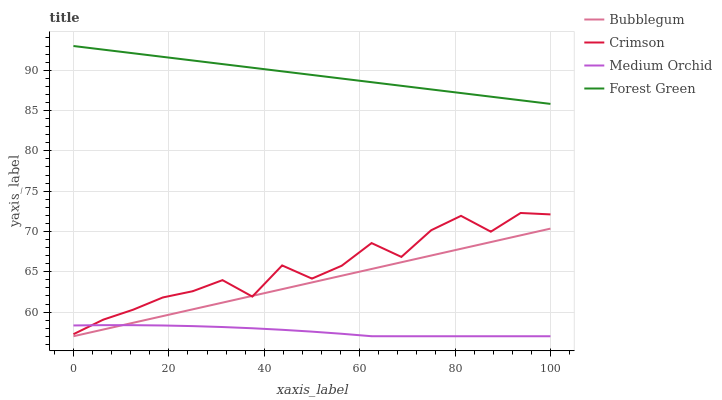Does Medium Orchid have the minimum area under the curve?
Answer yes or no. Yes. Does Forest Green have the maximum area under the curve?
Answer yes or no. Yes. Does Forest Green have the minimum area under the curve?
Answer yes or no. No. Does Medium Orchid have the maximum area under the curve?
Answer yes or no. No. Is Bubblegum the smoothest?
Answer yes or no. Yes. Is Crimson the roughest?
Answer yes or no. Yes. Is Forest Green the smoothest?
Answer yes or no. No. Is Forest Green the roughest?
Answer yes or no. No. Does Medium Orchid have the lowest value?
Answer yes or no. Yes. Does Forest Green have the lowest value?
Answer yes or no. No. Does Forest Green have the highest value?
Answer yes or no. Yes. Does Medium Orchid have the highest value?
Answer yes or no. No. Is Crimson less than Forest Green?
Answer yes or no. Yes. Is Forest Green greater than Bubblegum?
Answer yes or no. Yes. Does Crimson intersect Bubblegum?
Answer yes or no. Yes. Is Crimson less than Bubblegum?
Answer yes or no. No. Is Crimson greater than Bubblegum?
Answer yes or no. No. Does Crimson intersect Forest Green?
Answer yes or no. No. 